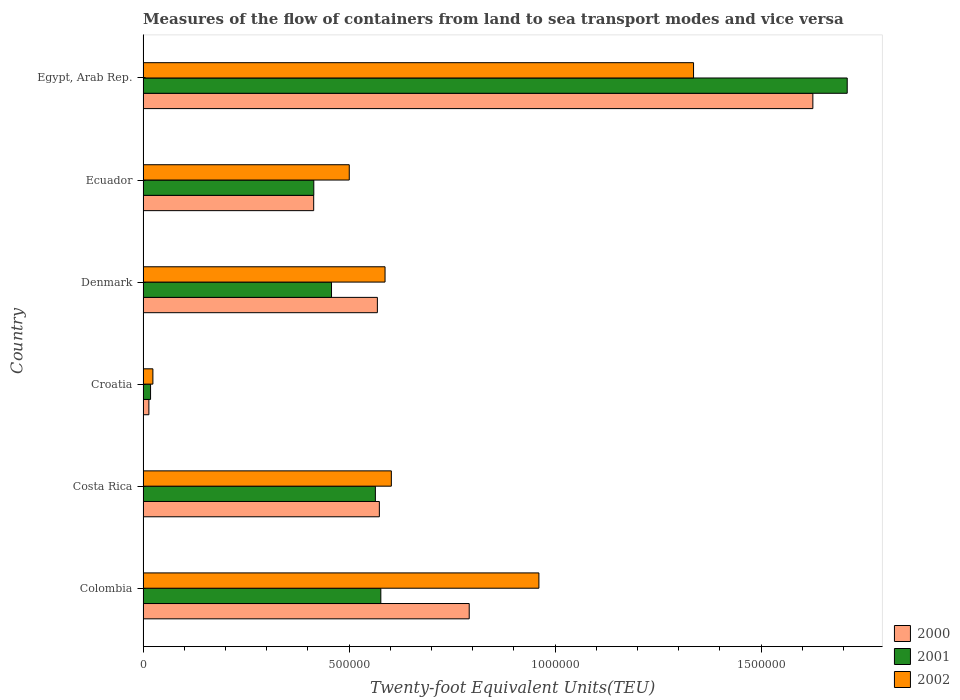Are the number of bars per tick equal to the number of legend labels?
Make the answer very short. Yes. Are the number of bars on each tick of the Y-axis equal?
Offer a terse response. Yes. What is the label of the 2nd group of bars from the top?
Provide a succinct answer. Ecuador. What is the container port traffic in 2002 in Ecuador?
Offer a very short reply. 5.00e+05. Across all countries, what is the maximum container port traffic in 2002?
Ensure brevity in your answer.  1.34e+06. Across all countries, what is the minimum container port traffic in 2002?
Your answer should be very brief. 2.39e+04. In which country was the container port traffic in 2001 maximum?
Offer a terse response. Egypt, Arab Rep. In which country was the container port traffic in 2002 minimum?
Ensure brevity in your answer.  Croatia. What is the total container port traffic in 2001 in the graph?
Offer a very short reply. 3.74e+06. What is the difference between the container port traffic in 2001 in Colombia and that in Denmark?
Your response must be concise. 1.20e+05. What is the difference between the container port traffic in 2002 in Denmark and the container port traffic in 2001 in Costa Rica?
Your response must be concise. 2.35e+04. What is the average container port traffic in 2002 per country?
Your answer should be very brief. 6.68e+05. What is the difference between the container port traffic in 2001 and container port traffic in 2000 in Denmark?
Ensure brevity in your answer.  -1.11e+05. In how many countries, is the container port traffic in 2001 greater than 1300000 TEU?
Your answer should be compact. 1. What is the ratio of the container port traffic in 2001 in Croatia to that in Egypt, Arab Rep.?
Make the answer very short. 0.01. Is the container port traffic in 2000 in Denmark less than that in Egypt, Arab Rep.?
Provide a succinct answer. Yes. What is the difference between the highest and the second highest container port traffic in 2002?
Your answer should be very brief. 3.75e+05. What is the difference between the highest and the lowest container port traffic in 2002?
Ensure brevity in your answer.  1.31e+06. In how many countries, is the container port traffic in 2000 greater than the average container port traffic in 2000 taken over all countries?
Your answer should be compact. 2. What does the 1st bar from the top in Costa Rica represents?
Keep it short and to the point. 2002. Are the values on the major ticks of X-axis written in scientific E-notation?
Give a very brief answer. No. Does the graph contain grids?
Provide a short and direct response. No. How are the legend labels stacked?
Make the answer very short. Vertical. What is the title of the graph?
Make the answer very short. Measures of the flow of containers from land to sea transport modes and vice versa. What is the label or title of the X-axis?
Provide a short and direct response. Twenty-foot Equivalent Units(TEU). What is the label or title of the Y-axis?
Provide a short and direct response. Country. What is the Twenty-foot Equivalent Units(TEU) of 2000 in Colombia?
Give a very brief answer. 7.92e+05. What is the Twenty-foot Equivalent Units(TEU) of 2001 in Colombia?
Your answer should be compact. 5.77e+05. What is the Twenty-foot Equivalent Units(TEU) in 2002 in Colombia?
Your answer should be very brief. 9.61e+05. What is the Twenty-foot Equivalent Units(TEU) in 2000 in Costa Rica?
Offer a terse response. 5.74e+05. What is the Twenty-foot Equivalent Units(TEU) of 2001 in Costa Rica?
Give a very brief answer. 5.64e+05. What is the Twenty-foot Equivalent Units(TEU) in 2002 in Costa Rica?
Make the answer very short. 6.03e+05. What is the Twenty-foot Equivalent Units(TEU) of 2000 in Croatia?
Provide a short and direct response. 1.42e+04. What is the Twenty-foot Equivalent Units(TEU) of 2001 in Croatia?
Offer a terse response. 1.82e+04. What is the Twenty-foot Equivalent Units(TEU) of 2002 in Croatia?
Give a very brief answer. 2.39e+04. What is the Twenty-foot Equivalent Units(TEU) of 2000 in Denmark?
Your answer should be compact. 5.69e+05. What is the Twenty-foot Equivalent Units(TEU) in 2001 in Denmark?
Keep it short and to the point. 4.57e+05. What is the Twenty-foot Equivalent Units(TEU) of 2002 in Denmark?
Make the answer very short. 5.87e+05. What is the Twenty-foot Equivalent Units(TEU) in 2000 in Ecuador?
Give a very brief answer. 4.14e+05. What is the Twenty-foot Equivalent Units(TEU) in 2001 in Ecuador?
Give a very brief answer. 4.14e+05. What is the Twenty-foot Equivalent Units(TEU) in 2002 in Ecuador?
Provide a succinct answer. 5.00e+05. What is the Twenty-foot Equivalent Units(TEU) of 2000 in Egypt, Arab Rep.?
Provide a succinct answer. 1.63e+06. What is the Twenty-foot Equivalent Units(TEU) in 2001 in Egypt, Arab Rep.?
Provide a succinct answer. 1.71e+06. What is the Twenty-foot Equivalent Units(TEU) in 2002 in Egypt, Arab Rep.?
Provide a short and direct response. 1.34e+06. Across all countries, what is the maximum Twenty-foot Equivalent Units(TEU) of 2000?
Provide a succinct answer. 1.63e+06. Across all countries, what is the maximum Twenty-foot Equivalent Units(TEU) in 2001?
Keep it short and to the point. 1.71e+06. Across all countries, what is the maximum Twenty-foot Equivalent Units(TEU) in 2002?
Give a very brief answer. 1.34e+06. Across all countries, what is the minimum Twenty-foot Equivalent Units(TEU) in 2000?
Provide a short and direct response. 1.42e+04. Across all countries, what is the minimum Twenty-foot Equivalent Units(TEU) of 2001?
Your answer should be compact. 1.82e+04. Across all countries, what is the minimum Twenty-foot Equivalent Units(TEU) in 2002?
Your response must be concise. 2.39e+04. What is the total Twenty-foot Equivalent Units(TEU) of 2000 in the graph?
Provide a short and direct response. 3.99e+06. What is the total Twenty-foot Equivalent Units(TEU) in 2001 in the graph?
Offer a very short reply. 3.74e+06. What is the total Twenty-foot Equivalent Units(TEU) of 2002 in the graph?
Your answer should be very brief. 4.01e+06. What is the difference between the Twenty-foot Equivalent Units(TEU) in 2000 in Colombia and that in Costa Rica?
Keep it short and to the point. 2.18e+05. What is the difference between the Twenty-foot Equivalent Units(TEU) of 2001 in Colombia and that in Costa Rica?
Offer a very short reply. 1.32e+04. What is the difference between the Twenty-foot Equivalent Units(TEU) in 2002 in Colombia and that in Costa Rica?
Your answer should be compact. 3.58e+05. What is the difference between the Twenty-foot Equivalent Units(TEU) of 2000 in Colombia and that in Croatia?
Give a very brief answer. 7.77e+05. What is the difference between the Twenty-foot Equivalent Units(TEU) of 2001 in Colombia and that in Croatia?
Provide a succinct answer. 5.59e+05. What is the difference between the Twenty-foot Equivalent Units(TEU) of 2002 in Colombia and that in Croatia?
Your answer should be very brief. 9.37e+05. What is the difference between the Twenty-foot Equivalent Units(TEU) in 2000 in Colombia and that in Denmark?
Your answer should be very brief. 2.23e+05. What is the difference between the Twenty-foot Equivalent Units(TEU) in 2001 in Colombia and that in Denmark?
Provide a succinct answer. 1.20e+05. What is the difference between the Twenty-foot Equivalent Units(TEU) of 2002 in Colombia and that in Denmark?
Keep it short and to the point. 3.73e+05. What is the difference between the Twenty-foot Equivalent Units(TEU) of 2000 in Colombia and that in Ecuador?
Provide a short and direct response. 3.77e+05. What is the difference between the Twenty-foot Equivalent Units(TEU) of 2001 in Colombia and that in Ecuador?
Your response must be concise. 1.63e+05. What is the difference between the Twenty-foot Equivalent Units(TEU) in 2002 in Colombia and that in Ecuador?
Give a very brief answer. 4.60e+05. What is the difference between the Twenty-foot Equivalent Units(TEU) of 2000 in Colombia and that in Egypt, Arab Rep.?
Your response must be concise. -8.34e+05. What is the difference between the Twenty-foot Equivalent Units(TEU) of 2001 in Colombia and that in Egypt, Arab Rep.?
Keep it short and to the point. -1.13e+06. What is the difference between the Twenty-foot Equivalent Units(TEU) of 2002 in Colombia and that in Egypt, Arab Rep.?
Make the answer very short. -3.75e+05. What is the difference between the Twenty-foot Equivalent Units(TEU) in 2000 in Costa Rica and that in Croatia?
Make the answer very short. 5.59e+05. What is the difference between the Twenty-foot Equivalent Units(TEU) of 2001 in Costa Rica and that in Croatia?
Offer a very short reply. 5.46e+05. What is the difference between the Twenty-foot Equivalent Units(TEU) of 2002 in Costa Rica and that in Croatia?
Make the answer very short. 5.79e+05. What is the difference between the Twenty-foot Equivalent Units(TEU) in 2000 in Costa Rica and that in Denmark?
Provide a succinct answer. 4842. What is the difference between the Twenty-foot Equivalent Units(TEU) in 2001 in Costa Rica and that in Denmark?
Keep it short and to the point. 1.06e+05. What is the difference between the Twenty-foot Equivalent Units(TEU) of 2002 in Costa Rica and that in Denmark?
Your answer should be compact. 1.53e+04. What is the difference between the Twenty-foot Equivalent Units(TEU) in 2000 in Costa Rica and that in Ecuador?
Ensure brevity in your answer.  1.59e+05. What is the difference between the Twenty-foot Equivalent Units(TEU) in 2001 in Costa Rica and that in Ecuador?
Keep it short and to the point. 1.49e+05. What is the difference between the Twenty-foot Equivalent Units(TEU) in 2002 in Costa Rica and that in Ecuador?
Keep it short and to the point. 1.02e+05. What is the difference between the Twenty-foot Equivalent Units(TEU) of 2000 in Costa Rica and that in Egypt, Arab Rep.?
Offer a terse response. -1.05e+06. What is the difference between the Twenty-foot Equivalent Units(TEU) of 2001 in Costa Rica and that in Egypt, Arab Rep.?
Keep it short and to the point. -1.15e+06. What is the difference between the Twenty-foot Equivalent Units(TEU) of 2002 in Costa Rica and that in Egypt, Arab Rep.?
Ensure brevity in your answer.  -7.33e+05. What is the difference between the Twenty-foot Equivalent Units(TEU) in 2000 in Croatia and that in Denmark?
Offer a very short reply. -5.55e+05. What is the difference between the Twenty-foot Equivalent Units(TEU) in 2001 in Croatia and that in Denmark?
Make the answer very short. -4.39e+05. What is the difference between the Twenty-foot Equivalent Units(TEU) of 2002 in Croatia and that in Denmark?
Offer a terse response. -5.63e+05. What is the difference between the Twenty-foot Equivalent Units(TEU) in 2000 in Croatia and that in Ecuador?
Provide a short and direct response. -4.00e+05. What is the difference between the Twenty-foot Equivalent Units(TEU) of 2001 in Croatia and that in Ecuador?
Offer a very short reply. -3.96e+05. What is the difference between the Twenty-foot Equivalent Units(TEU) in 2002 in Croatia and that in Ecuador?
Provide a succinct answer. -4.77e+05. What is the difference between the Twenty-foot Equivalent Units(TEU) of 2000 in Croatia and that in Egypt, Arab Rep.?
Give a very brief answer. -1.61e+06. What is the difference between the Twenty-foot Equivalent Units(TEU) of 2001 in Croatia and that in Egypt, Arab Rep.?
Provide a short and direct response. -1.69e+06. What is the difference between the Twenty-foot Equivalent Units(TEU) in 2002 in Croatia and that in Egypt, Arab Rep.?
Provide a succinct answer. -1.31e+06. What is the difference between the Twenty-foot Equivalent Units(TEU) in 2000 in Denmark and that in Ecuador?
Provide a short and direct response. 1.55e+05. What is the difference between the Twenty-foot Equivalent Units(TEU) of 2001 in Denmark and that in Ecuador?
Provide a succinct answer. 4.30e+04. What is the difference between the Twenty-foot Equivalent Units(TEU) of 2002 in Denmark and that in Ecuador?
Your answer should be very brief. 8.68e+04. What is the difference between the Twenty-foot Equivalent Units(TEU) of 2000 in Denmark and that in Egypt, Arab Rep.?
Offer a terse response. -1.06e+06. What is the difference between the Twenty-foot Equivalent Units(TEU) of 2001 in Denmark and that in Egypt, Arab Rep.?
Make the answer very short. -1.25e+06. What is the difference between the Twenty-foot Equivalent Units(TEU) of 2002 in Denmark and that in Egypt, Arab Rep.?
Your answer should be compact. -7.49e+05. What is the difference between the Twenty-foot Equivalent Units(TEU) of 2000 in Ecuador and that in Egypt, Arab Rep.?
Ensure brevity in your answer.  -1.21e+06. What is the difference between the Twenty-foot Equivalent Units(TEU) of 2001 in Ecuador and that in Egypt, Arab Rep.?
Provide a succinct answer. -1.29e+06. What is the difference between the Twenty-foot Equivalent Units(TEU) of 2002 in Ecuador and that in Egypt, Arab Rep.?
Your response must be concise. -8.36e+05. What is the difference between the Twenty-foot Equivalent Units(TEU) in 2000 in Colombia and the Twenty-foot Equivalent Units(TEU) in 2001 in Costa Rica?
Provide a short and direct response. 2.28e+05. What is the difference between the Twenty-foot Equivalent Units(TEU) in 2000 in Colombia and the Twenty-foot Equivalent Units(TEU) in 2002 in Costa Rica?
Keep it short and to the point. 1.89e+05. What is the difference between the Twenty-foot Equivalent Units(TEU) in 2001 in Colombia and the Twenty-foot Equivalent Units(TEU) in 2002 in Costa Rica?
Your response must be concise. -2.55e+04. What is the difference between the Twenty-foot Equivalent Units(TEU) of 2000 in Colombia and the Twenty-foot Equivalent Units(TEU) of 2001 in Croatia?
Provide a succinct answer. 7.73e+05. What is the difference between the Twenty-foot Equivalent Units(TEU) in 2000 in Colombia and the Twenty-foot Equivalent Units(TEU) in 2002 in Croatia?
Offer a terse response. 7.68e+05. What is the difference between the Twenty-foot Equivalent Units(TEU) of 2001 in Colombia and the Twenty-foot Equivalent Units(TEU) of 2002 in Croatia?
Provide a short and direct response. 5.53e+05. What is the difference between the Twenty-foot Equivalent Units(TEU) in 2000 in Colombia and the Twenty-foot Equivalent Units(TEU) in 2001 in Denmark?
Your response must be concise. 3.34e+05. What is the difference between the Twenty-foot Equivalent Units(TEU) in 2000 in Colombia and the Twenty-foot Equivalent Units(TEU) in 2002 in Denmark?
Ensure brevity in your answer.  2.04e+05. What is the difference between the Twenty-foot Equivalent Units(TEU) in 2001 in Colombia and the Twenty-foot Equivalent Units(TEU) in 2002 in Denmark?
Offer a terse response. -1.03e+04. What is the difference between the Twenty-foot Equivalent Units(TEU) in 2000 in Colombia and the Twenty-foot Equivalent Units(TEU) in 2001 in Ecuador?
Your answer should be compact. 3.77e+05. What is the difference between the Twenty-foot Equivalent Units(TEU) in 2000 in Colombia and the Twenty-foot Equivalent Units(TEU) in 2002 in Ecuador?
Make the answer very short. 2.91e+05. What is the difference between the Twenty-foot Equivalent Units(TEU) of 2001 in Colombia and the Twenty-foot Equivalent Units(TEU) of 2002 in Ecuador?
Your answer should be compact. 7.66e+04. What is the difference between the Twenty-foot Equivalent Units(TEU) in 2000 in Colombia and the Twenty-foot Equivalent Units(TEU) in 2001 in Egypt, Arab Rep.?
Your response must be concise. -9.17e+05. What is the difference between the Twenty-foot Equivalent Units(TEU) in 2000 in Colombia and the Twenty-foot Equivalent Units(TEU) in 2002 in Egypt, Arab Rep.?
Keep it short and to the point. -5.44e+05. What is the difference between the Twenty-foot Equivalent Units(TEU) of 2001 in Colombia and the Twenty-foot Equivalent Units(TEU) of 2002 in Egypt, Arab Rep.?
Give a very brief answer. -7.59e+05. What is the difference between the Twenty-foot Equivalent Units(TEU) in 2000 in Costa Rica and the Twenty-foot Equivalent Units(TEU) in 2001 in Croatia?
Provide a short and direct response. 5.55e+05. What is the difference between the Twenty-foot Equivalent Units(TEU) in 2000 in Costa Rica and the Twenty-foot Equivalent Units(TEU) in 2002 in Croatia?
Your answer should be compact. 5.50e+05. What is the difference between the Twenty-foot Equivalent Units(TEU) of 2001 in Costa Rica and the Twenty-foot Equivalent Units(TEU) of 2002 in Croatia?
Your answer should be compact. 5.40e+05. What is the difference between the Twenty-foot Equivalent Units(TEU) of 2000 in Costa Rica and the Twenty-foot Equivalent Units(TEU) of 2001 in Denmark?
Offer a terse response. 1.16e+05. What is the difference between the Twenty-foot Equivalent Units(TEU) of 2000 in Costa Rica and the Twenty-foot Equivalent Units(TEU) of 2002 in Denmark?
Provide a short and direct response. -1.38e+04. What is the difference between the Twenty-foot Equivalent Units(TEU) in 2001 in Costa Rica and the Twenty-foot Equivalent Units(TEU) in 2002 in Denmark?
Offer a terse response. -2.35e+04. What is the difference between the Twenty-foot Equivalent Units(TEU) of 2000 in Costa Rica and the Twenty-foot Equivalent Units(TEU) of 2001 in Ecuador?
Your answer should be very brief. 1.59e+05. What is the difference between the Twenty-foot Equivalent Units(TEU) in 2000 in Costa Rica and the Twenty-foot Equivalent Units(TEU) in 2002 in Ecuador?
Make the answer very short. 7.30e+04. What is the difference between the Twenty-foot Equivalent Units(TEU) in 2001 in Costa Rica and the Twenty-foot Equivalent Units(TEU) in 2002 in Ecuador?
Ensure brevity in your answer.  6.34e+04. What is the difference between the Twenty-foot Equivalent Units(TEU) of 2000 in Costa Rica and the Twenty-foot Equivalent Units(TEU) of 2001 in Egypt, Arab Rep.?
Your response must be concise. -1.14e+06. What is the difference between the Twenty-foot Equivalent Units(TEU) of 2000 in Costa Rica and the Twenty-foot Equivalent Units(TEU) of 2002 in Egypt, Arab Rep.?
Your answer should be compact. -7.63e+05. What is the difference between the Twenty-foot Equivalent Units(TEU) of 2001 in Costa Rica and the Twenty-foot Equivalent Units(TEU) of 2002 in Egypt, Arab Rep.?
Your response must be concise. -7.72e+05. What is the difference between the Twenty-foot Equivalent Units(TEU) of 2000 in Croatia and the Twenty-foot Equivalent Units(TEU) of 2001 in Denmark?
Offer a terse response. -4.43e+05. What is the difference between the Twenty-foot Equivalent Units(TEU) in 2000 in Croatia and the Twenty-foot Equivalent Units(TEU) in 2002 in Denmark?
Your answer should be very brief. -5.73e+05. What is the difference between the Twenty-foot Equivalent Units(TEU) in 2001 in Croatia and the Twenty-foot Equivalent Units(TEU) in 2002 in Denmark?
Your answer should be compact. -5.69e+05. What is the difference between the Twenty-foot Equivalent Units(TEU) in 2000 in Croatia and the Twenty-foot Equivalent Units(TEU) in 2001 in Ecuador?
Give a very brief answer. -4.00e+05. What is the difference between the Twenty-foot Equivalent Units(TEU) of 2000 in Croatia and the Twenty-foot Equivalent Units(TEU) of 2002 in Ecuador?
Ensure brevity in your answer.  -4.86e+05. What is the difference between the Twenty-foot Equivalent Units(TEU) of 2001 in Croatia and the Twenty-foot Equivalent Units(TEU) of 2002 in Ecuador?
Your answer should be compact. -4.82e+05. What is the difference between the Twenty-foot Equivalent Units(TEU) in 2000 in Croatia and the Twenty-foot Equivalent Units(TEU) in 2001 in Egypt, Arab Rep.?
Offer a very short reply. -1.69e+06. What is the difference between the Twenty-foot Equivalent Units(TEU) of 2000 in Croatia and the Twenty-foot Equivalent Units(TEU) of 2002 in Egypt, Arab Rep.?
Your answer should be very brief. -1.32e+06. What is the difference between the Twenty-foot Equivalent Units(TEU) of 2001 in Croatia and the Twenty-foot Equivalent Units(TEU) of 2002 in Egypt, Arab Rep.?
Your response must be concise. -1.32e+06. What is the difference between the Twenty-foot Equivalent Units(TEU) of 2000 in Denmark and the Twenty-foot Equivalent Units(TEU) of 2001 in Ecuador?
Your answer should be compact. 1.54e+05. What is the difference between the Twenty-foot Equivalent Units(TEU) of 2000 in Denmark and the Twenty-foot Equivalent Units(TEU) of 2002 in Ecuador?
Ensure brevity in your answer.  6.82e+04. What is the difference between the Twenty-foot Equivalent Units(TEU) of 2001 in Denmark and the Twenty-foot Equivalent Units(TEU) of 2002 in Ecuador?
Provide a short and direct response. -4.31e+04. What is the difference between the Twenty-foot Equivalent Units(TEU) in 2000 in Denmark and the Twenty-foot Equivalent Units(TEU) in 2001 in Egypt, Arab Rep.?
Provide a succinct answer. -1.14e+06. What is the difference between the Twenty-foot Equivalent Units(TEU) in 2000 in Denmark and the Twenty-foot Equivalent Units(TEU) in 2002 in Egypt, Arab Rep.?
Keep it short and to the point. -7.67e+05. What is the difference between the Twenty-foot Equivalent Units(TEU) in 2001 in Denmark and the Twenty-foot Equivalent Units(TEU) in 2002 in Egypt, Arab Rep.?
Keep it short and to the point. -8.79e+05. What is the difference between the Twenty-foot Equivalent Units(TEU) of 2000 in Ecuador and the Twenty-foot Equivalent Units(TEU) of 2001 in Egypt, Arab Rep.?
Your response must be concise. -1.29e+06. What is the difference between the Twenty-foot Equivalent Units(TEU) of 2000 in Ecuador and the Twenty-foot Equivalent Units(TEU) of 2002 in Egypt, Arab Rep.?
Provide a short and direct response. -9.22e+05. What is the difference between the Twenty-foot Equivalent Units(TEU) of 2001 in Ecuador and the Twenty-foot Equivalent Units(TEU) of 2002 in Egypt, Arab Rep.?
Your response must be concise. -9.22e+05. What is the average Twenty-foot Equivalent Units(TEU) in 2000 per country?
Provide a succinct answer. 6.65e+05. What is the average Twenty-foot Equivalent Units(TEU) in 2001 per country?
Provide a succinct answer. 6.23e+05. What is the average Twenty-foot Equivalent Units(TEU) of 2002 per country?
Provide a short and direct response. 6.68e+05. What is the difference between the Twenty-foot Equivalent Units(TEU) in 2000 and Twenty-foot Equivalent Units(TEU) in 2001 in Colombia?
Your answer should be very brief. 2.15e+05. What is the difference between the Twenty-foot Equivalent Units(TEU) in 2000 and Twenty-foot Equivalent Units(TEU) in 2002 in Colombia?
Keep it short and to the point. -1.69e+05. What is the difference between the Twenty-foot Equivalent Units(TEU) in 2001 and Twenty-foot Equivalent Units(TEU) in 2002 in Colombia?
Offer a very short reply. -3.84e+05. What is the difference between the Twenty-foot Equivalent Units(TEU) in 2000 and Twenty-foot Equivalent Units(TEU) in 2001 in Costa Rica?
Offer a very short reply. 9677. What is the difference between the Twenty-foot Equivalent Units(TEU) in 2000 and Twenty-foot Equivalent Units(TEU) in 2002 in Costa Rica?
Offer a very short reply. -2.91e+04. What is the difference between the Twenty-foot Equivalent Units(TEU) of 2001 and Twenty-foot Equivalent Units(TEU) of 2002 in Costa Rica?
Make the answer very short. -3.87e+04. What is the difference between the Twenty-foot Equivalent Units(TEU) in 2000 and Twenty-foot Equivalent Units(TEU) in 2001 in Croatia?
Provide a short and direct response. -4065. What is the difference between the Twenty-foot Equivalent Units(TEU) in 2000 and Twenty-foot Equivalent Units(TEU) in 2002 in Croatia?
Ensure brevity in your answer.  -9700. What is the difference between the Twenty-foot Equivalent Units(TEU) in 2001 and Twenty-foot Equivalent Units(TEU) in 2002 in Croatia?
Offer a terse response. -5635. What is the difference between the Twenty-foot Equivalent Units(TEU) of 2000 and Twenty-foot Equivalent Units(TEU) of 2001 in Denmark?
Provide a succinct answer. 1.11e+05. What is the difference between the Twenty-foot Equivalent Units(TEU) in 2000 and Twenty-foot Equivalent Units(TEU) in 2002 in Denmark?
Provide a succinct answer. -1.86e+04. What is the difference between the Twenty-foot Equivalent Units(TEU) of 2001 and Twenty-foot Equivalent Units(TEU) of 2002 in Denmark?
Make the answer very short. -1.30e+05. What is the difference between the Twenty-foot Equivalent Units(TEU) of 2000 and Twenty-foot Equivalent Units(TEU) of 2001 in Ecuador?
Your answer should be very brief. -251. What is the difference between the Twenty-foot Equivalent Units(TEU) in 2000 and Twenty-foot Equivalent Units(TEU) in 2002 in Ecuador?
Your answer should be compact. -8.64e+04. What is the difference between the Twenty-foot Equivalent Units(TEU) of 2001 and Twenty-foot Equivalent Units(TEU) of 2002 in Ecuador?
Offer a very short reply. -8.61e+04. What is the difference between the Twenty-foot Equivalent Units(TEU) in 2000 and Twenty-foot Equivalent Units(TEU) in 2001 in Egypt, Arab Rep.?
Offer a very short reply. -8.34e+04. What is the difference between the Twenty-foot Equivalent Units(TEU) of 2000 and Twenty-foot Equivalent Units(TEU) of 2002 in Egypt, Arab Rep.?
Keep it short and to the point. 2.90e+05. What is the difference between the Twenty-foot Equivalent Units(TEU) in 2001 and Twenty-foot Equivalent Units(TEU) in 2002 in Egypt, Arab Rep.?
Make the answer very short. 3.73e+05. What is the ratio of the Twenty-foot Equivalent Units(TEU) of 2000 in Colombia to that in Costa Rica?
Ensure brevity in your answer.  1.38. What is the ratio of the Twenty-foot Equivalent Units(TEU) in 2001 in Colombia to that in Costa Rica?
Keep it short and to the point. 1.02. What is the ratio of the Twenty-foot Equivalent Units(TEU) of 2002 in Colombia to that in Costa Rica?
Your answer should be very brief. 1.59. What is the ratio of the Twenty-foot Equivalent Units(TEU) of 2000 in Colombia to that in Croatia?
Offer a terse response. 55.93. What is the ratio of the Twenty-foot Equivalent Units(TEU) in 2001 in Colombia to that in Croatia?
Your response must be concise. 31.67. What is the ratio of the Twenty-foot Equivalent Units(TEU) of 2002 in Colombia to that in Croatia?
Keep it short and to the point. 40.28. What is the ratio of the Twenty-foot Equivalent Units(TEU) in 2000 in Colombia to that in Denmark?
Provide a succinct answer. 1.39. What is the ratio of the Twenty-foot Equivalent Units(TEU) in 2001 in Colombia to that in Denmark?
Give a very brief answer. 1.26. What is the ratio of the Twenty-foot Equivalent Units(TEU) of 2002 in Colombia to that in Denmark?
Your answer should be compact. 1.64. What is the ratio of the Twenty-foot Equivalent Units(TEU) in 2000 in Colombia to that in Ecuador?
Give a very brief answer. 1.91. What is the ratio of the Twenty-foot Equivalent Units(TEU) in 2001 in Colombia to that in Ecuador?
Provide a short and direct response. 1.39. What is the ratio of the Twenty-foot Equivalent Units(TEU) in 2002 in Colombia to that in Ecuador?
Your response must be concise. 1.92. What is the ratio of the Twenty-foot Equivalent Units(TEU) in 2000 in Colombia to that in Egypt, Arab Rep.?
Your answer should be compact. 0.49. What is the ratio of the Twenty-foot Equivalent Units(TEU) of 2001 in Colombia to that in Egypt, Arab Rep.?
Make the answer very short. 0.34. What is the ratio of the Twenty-foot Equivalent Units(TEU) in 2002 in Colombia to that in Egypt, Arab Rep.?
Make the answer very short. 0.72. What is the ratio of the Twenty-foot Equivalent Units(TEU) of 2000 in Costa Rica to that in Croatia?
Provide a short and direct response. 40.52. What is the ratio of the Twenty-foot Equivalent Units(TEU) of 2001 in Costa Rica to that in Croatia?
Make the answer very short. 30.95. What is the ratio of the Twenty-foot Equivalent Units(TEU) in 2002 in Costa Rica to that in Croatia?
Your answer should be very brief. 25.26. What is the ratio of the Twenty-foot Equivalent Units(TEU) of 2000 in Costa Rica to that in Denmark?
Ensure brevity in your answer.  1.01. What is the ratio of the Twenty-foot Equivalent Units(TEU) in 2001 in Costa Rica to that in Denmark?
Provide a short and direct response. 1.23. What is the ratio of the Twenty-foot Equivalent Units(TEU) of 2000 in Costa Rica to that in Ecuador?
Provide a short and direct response. 1.38. What is the ratio of the Twenty-foot Equivalent Units(TEU) in 2001 in Costa Rica to that in Ecuador?
Keep it short and to the point. 1.36. What is the ratio of the Twenty-foot Equivalent Units(TEU) of 2002 in Costa Rica to that in Ecuador?
Your response must be concise. 1.2. What is the ratio of the Twenty-foot Equivalent Units(TEU) in 2000 in Costa Rica to that in Egypt, Arab Rep.?
Offer a very short reply. 0.35. What is the ratio of the Twenty-foot Equivalent Units(TEU) of 2001 in Costa Rica to that in Egypt, Arab Rep.?
Provide a succinct answer. 0.33. What is the ratio of the Twenty-foot Equivalent Units(TEU) of 2002 in Costa Rica to that in Egypt, Arab Rep.?
Give a very brief answer. 0.45. What is the ratio of the Twenty-foot Equivalent Units(TEU) of 2000 in Croatia to that in Denmark?
Your answer should be compact. 0.02. What is the ratio of the Twenty-foot Equivalent Units(TEU) in 2001 in Croatia to that in Denmark?
Make the answer very short. 0.04. What is the ratio of the Twenty-foot Equivalent Units(TEU) of 2002 in Croatia to that in Denmark?
Your response must be concise. 0.04. What is the ratio of the Twenty-foot Equivalent Units(TEU) in 2000 in Croatia to that in Ecuador?
Offer a very short reply. 0.03. What is the ratio of the Twenty-foot Equivalent Units(TEU) in 2001 in Croatia to that in Ecuador?
Offer a very short reply. 0.04. What is the ratio of the Twenty-foot Equivalent Units(TEU) of 2002 in Croatia to that in Ecuador?
Ensure brevity in your answer.  0.05. What is the ratio of the Twenty-foot Equivalent Units(TEU) of 2000 in Croatia to that in Egypt, Arab Rep.?
Your response must be concise. 0.01. What is the ratio of the Twenty-foot Equivalent Units(TEU) of 2001 in Croatia to that in Egypt, Arab Rep.?
Provide a short and direct response. 0.01. What is the ratio of the Twenty-foot Equivalent Units(TEU) of 2002 in Croatia to that in Egypt, Arab Rep.?
Offer a terse response. 0.02. What is the ratio of the Twenty-foot Equivalent Units(TEU) in 2000 in Denmark to that in Ecuador?
Make the answer very short. 1.37. What is the ratio of the Twenty-foot Equivalent Units(TEU) in 2001 in Denmark to that in Ecuador?
Ensure brevity in your answer.  1.1. What is the ratio of the Twenty-foot Equivalent Units(TEU) of 2002 in Denmark to that in Ecuador?
Offer a very short reply. 1.17. What is the ratio of the Twenty-foot Equivalent Units(TEU) of 2000 in Denmark to that in Egypt, Arab Rep.?
Offer a very short reply. 0.35. What is the ratio of the Twenty-foot Equivalent Units(TEU) in 2001 in Denmark to that in Egypt, Arab Rep.?
Make the answer very short. 0.27. What is the ratio of the Twenty-foot Equivalent Units(TEU) of 2002 in Denmark to that in Egypt, Arab Rep.?
Make the answer very short. 0.44. What is the ratio of the Twenty-foot Equivalent Units(TEU) in 2000 in Ecuador to that in Egypt, Arab Rep.?
Keep it short and to the point. 0.25. What is the ratio of the Twenty-foot Equivalent Units(TEU) of 2001 in Ecuador to that in Egypt, Arab Rep.?
Your response must be concise. 0.24. What is the ratio of the Twenty-foot Equivalent Units(TEU) of 2002 in Ecuador to that in Egypt, Arab Rep.?
Ensure brevity in your answer.  0.37. What is the difference between the highest and the second highest Twenty-foot Equivalent Units(TEU) of 2000?
Keep it short and to the point. 8.34e+05. What is the difference between the highest and the second highest Twenty-foot Equivalent Units(TEU) in 2001?
Offer a terse response. 1.13e+06. What is the difference between the highest and the second highest Twenty-foot Equivalent Units(TEU) of 2002?
Make the answer very short. 3.75e+05. What is the difference between the highest and the lowest Twenty-foot Equivalent Units(TEU) in 2000?
Your response must be concise. 1.61e+06. What is the difference between the highest and the lowest Twenty-foot Equivalent Units(TEU) of 2001?
Ensure brevity in your answer.  1.69e+06. What is the difference between the highest and the lowest Twenty-foot Equivalent Units(TEU) of 2002?
Offer a terse response. 1.31e+06. 